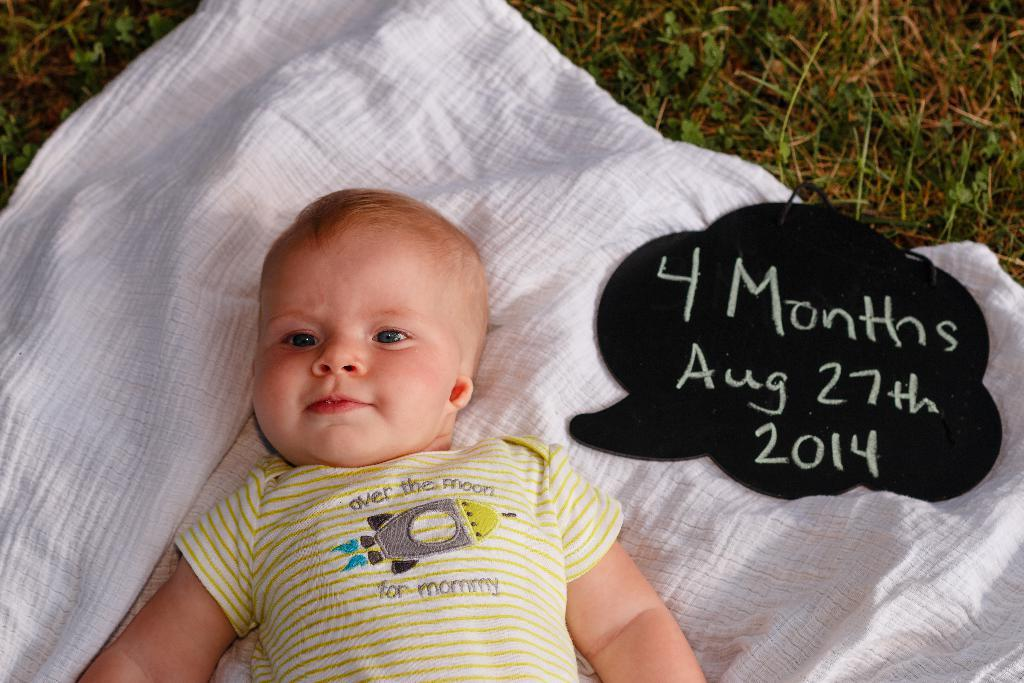What is the main subject in the center of the image? There is a baby in the center of the image. What is the baby resting on or covered by? There is a blanket under the baby. What can be seen on the right side of the image? There is some text on the right side of the image. What type of natural environment is visible in the background of the image? There is grass visible in the background of the image. How much money is the baby holding in the image? The baby is not holding any money in the image. What type of calculator is being used by the baby in the image? There is no calculator present in the image. 